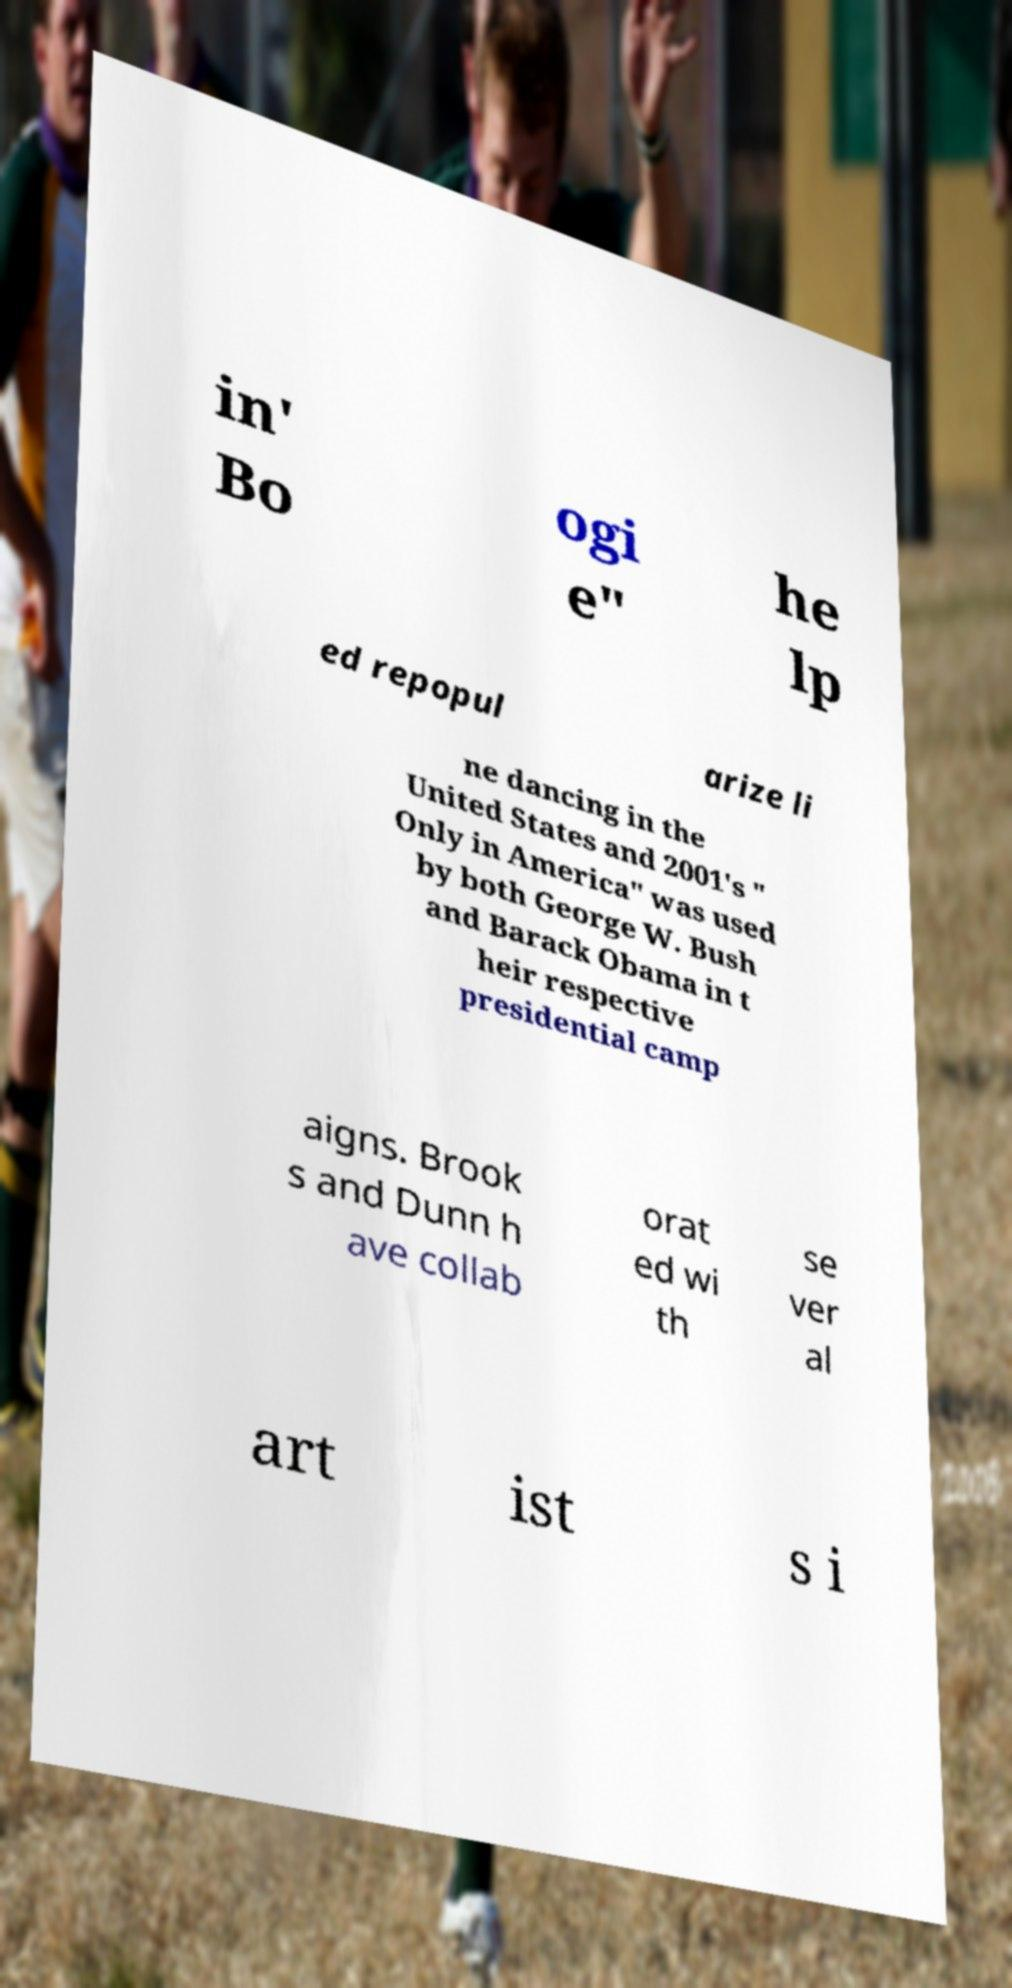Can you accurately transcribe the text from the provided image for me? in' Bo ogi e" he lp ed repopul arize li ne dancing in the United States and 2001's " Only in America" was used by both George W. Bush and Barack Obama in t heir respective presidential camp aigns. Brook s and Dunn h ave collab orat ed wi th se ver al art ist s i 